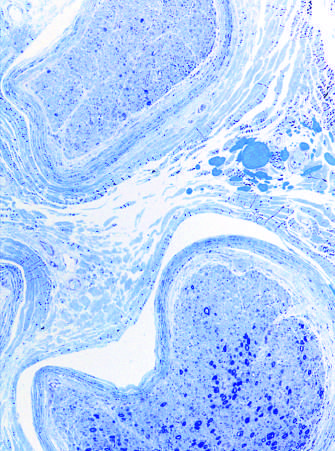what is often seen in neuropathies resulting from vascular injury?
Answer the question using a single word or phrase. Interfascicular variation in axonal density 